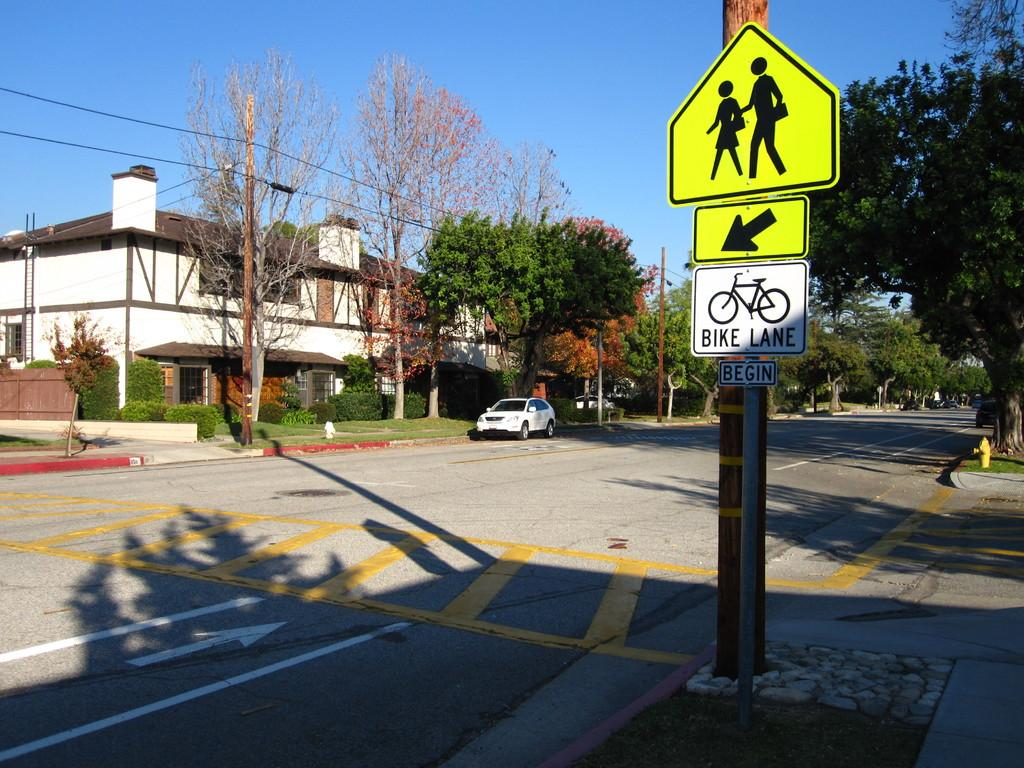Provide a one-sentence caption for the provided image. A street in Fall where the Bike lane begins. 